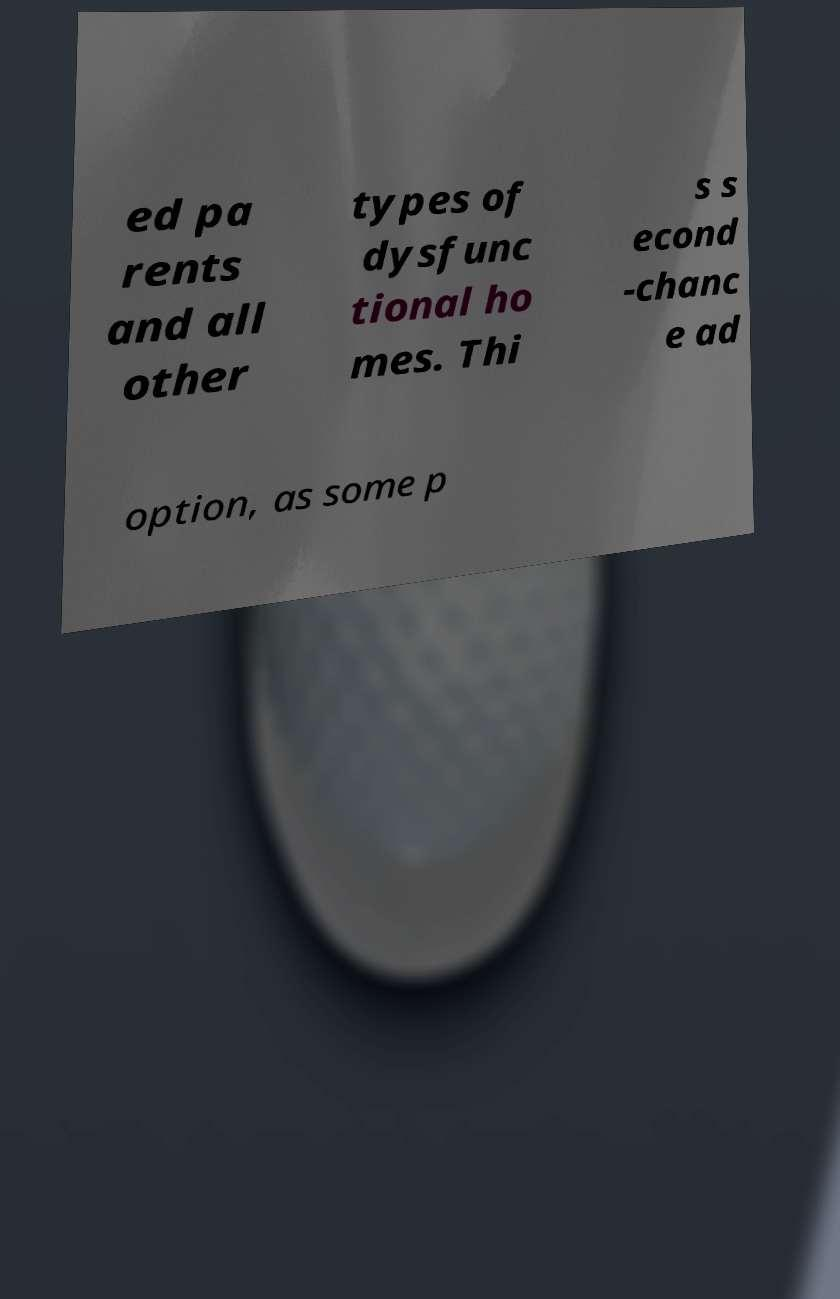I need the written content from this picture converted into text. Can you do that? ed pa rents and all other types of dysfunc tional ho mes. Thi s s econd -chanc e ad option, as some p 